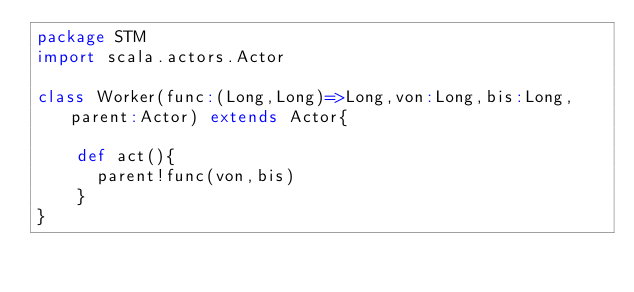Convert code to text. <code><loc_0><loc_0><loc_500><loc_500><_Scala_>package STM
import scala.actors.Actor

class Worker(func:(Long,Long)=>Long,von:Long,bis:Long,parent:Actor) extends Actor{
  
	def act(){
	  parent!func(von,bis)
	}
}</code> 